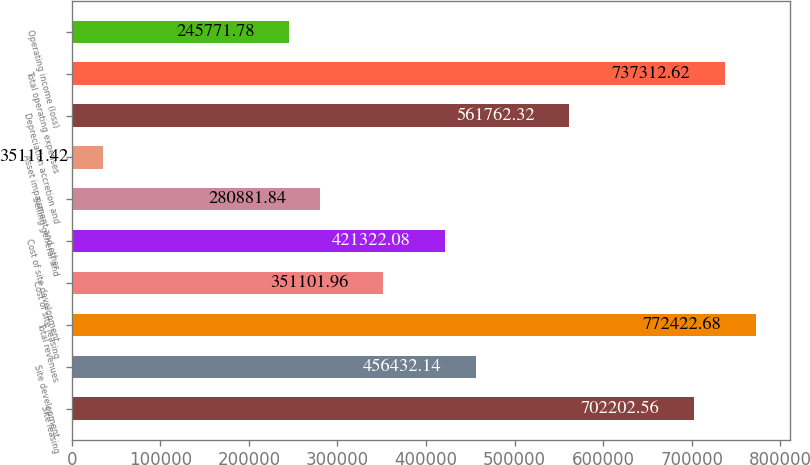Convert chart. <chart><loc_0><loc_0><loc_500><loc_500><bar_chart><fcel>Site leasing<fcel>Site development<fcel>Total revenues<fcel>Cost of site leasing<fcel>Cost of site development<fcel>Selling general and<fcel>Asset impairment and other<fcel>Depreciation accretion and<fcel>Total operating expenses<fcel>Operating income (loss)<nl><fcel>702203<fcel>456432<fcel>772423<fcel>351102<fcel>421322<fcel>280882<fcel>35111.4<fcel>561762<fcel>737313<fcel>245772<nl></chart> 